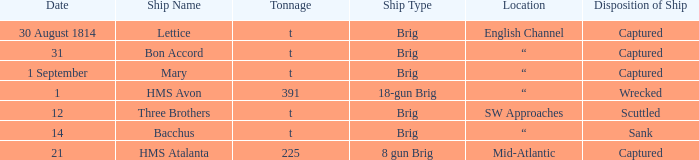With a capacity of 225, what is the kind of ship? 8 gun Brig. 